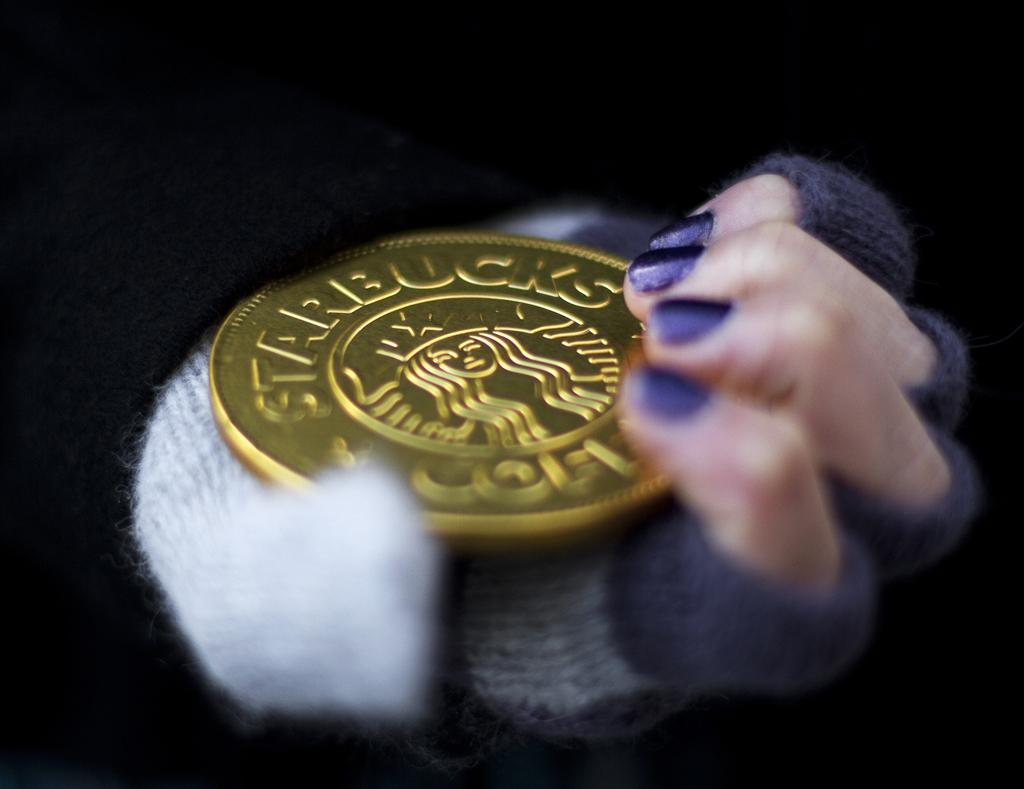What is being held in the person's hand in the image? There is a person's hand holding a coin in the image. What can be observed about the lighting in the image? The background of the image is dark. What type of dress is the person wearing in the image? There is no information about the person's clothing in the image, so we cannot determine if they are wearing a dress or not. 